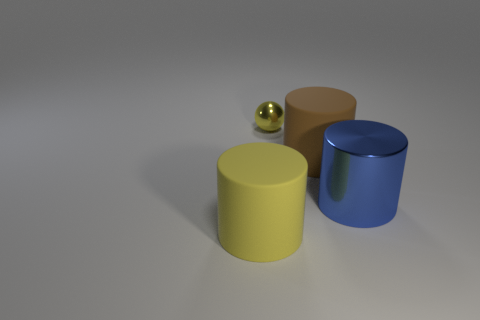Are there any other things that are the same size as the yellow metal object?
Make the answer very short. No. Are there any purple metallic things that have the same size as the blue thing?
Provide a short and direct response. No. Does the rubber thing that is left of the brown thing have the same color as the tiny metallic thing?
Your answer should be very brief. Yes. How many cyan objects are big cylinders or small metallic balls?
Give a very brief answer. 0. How many big metal cylinders have the same color as the large metal thing?
Offer a terse response. 0. Is the ball made of the same material as the large blue cylinder?
Keep it short and to the point. Yes. How many things are to the right of the large matte thing on the left side of the yellow sphere?
Your answer should be very brief. 3. Do the metallic ball and the brown rubber cylinder have the same size?
Give a very brief answer. No. How many large brown cylinders have the same material as the tiny yellow sphere?
Offer a very short reply. 0. There is a brown rubber thing that is the same shape as the big blue object; what is its size?
Your response must be concise. Large. 